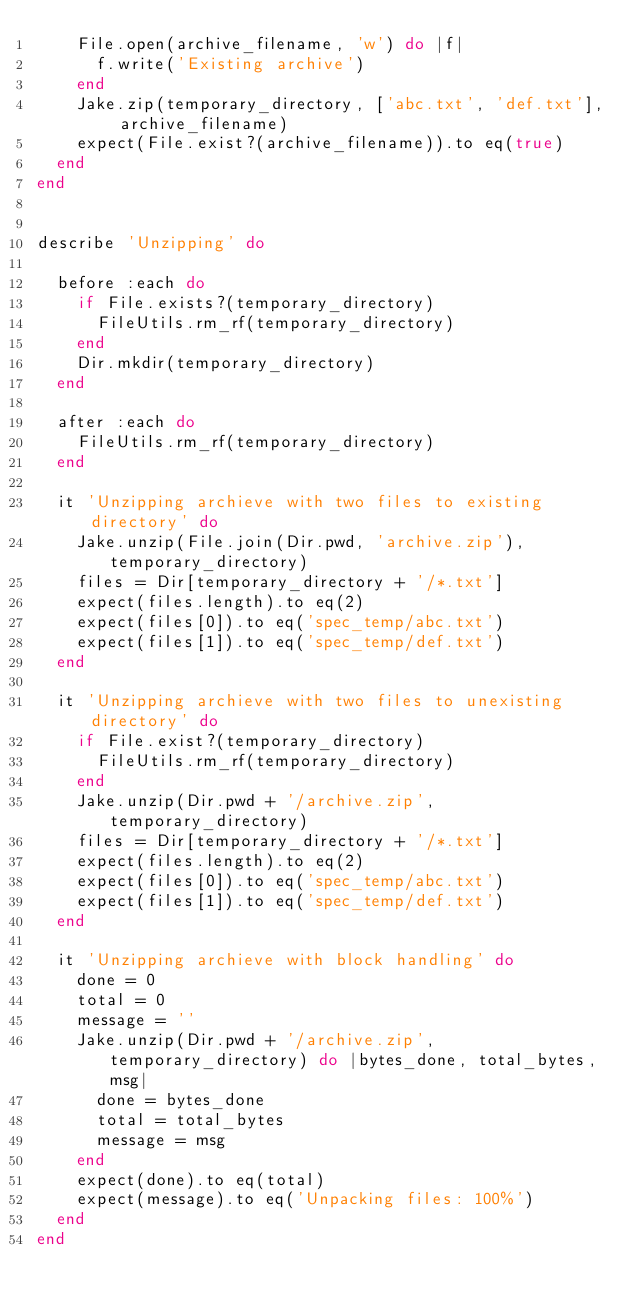<code> <loc_0><loc_0><loc_500><loc_500><_Ruby_>    File.open(archive_filename, 'w') do |f|
      f.write('Existing archive')
    end
    Jake.zip(temporary_directory, ['abc.txt', 'def.txt'], archive_filename)
    expect(File.exist?(archive_filename)).to eq(true)
  end
end


describe 'Unzipping' do

  before :each do
    if File.exists?(temporary_directory)
      FileUtils.rm_rf(temporary_directory)
    end
    Dir.mkdir(temporary_directory)
  end

  after :each do
    FileUtils.rm_rf(temporary_directory)
  end

  it 'Unzipping archieve with two files to existing directory' do
    Jake.unzip(File.join(Dir.pwd, 'archive.zip'), temporary_directory)
    files = Dir[temporary_directory + '/*.txt']
    expect(files.length).to eq(2)
    expect(files[0]).to eq('spec_temp/abc.txt')
    expect(files[1]).to eq('spec_temp/def.txt')
  end

  it 'Unzipping archieve with two files to unexisting directory' do
    if File.exist?(temporary_directory)
      FileUtils.rm_rf(temporary_directory)
    end
    Jake.unzip(Dir.pwd + '/archive.zip', temporary_directory)
    files = Dir[temporary_directory + '/*.txt']
    expect(files.length).to eq(2)
    expect(files[0]).to eq('spec_temp/abc.txt')
    expect(files[1]).to eq('spec_temp/def.txt')
  end

  it 'Unzipping archieve with block handling' do
    done = 0
    total = 0
    message = ''
    Jake.unzip(Dir.pwd + '/archive.zip', temporary_directory) do |bytes_done, total_bytes, msg|
      done = bytes_done
      total = total_bytes
      message = msg
    end
    expect(done).to eq(total)
    expect(message).to eq('Unpacking files: 100%')
  end
end</code> 